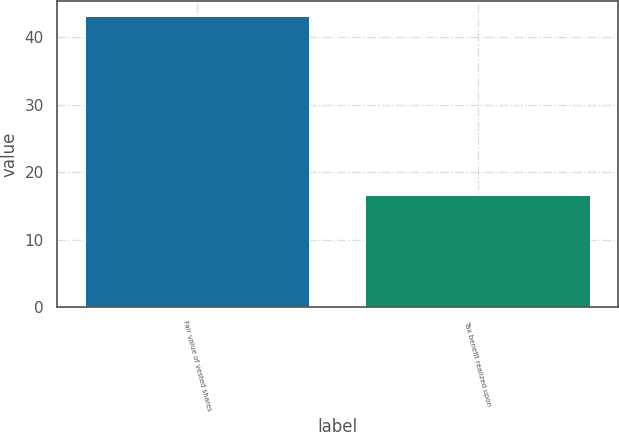<chart> <loc_0><loc_0><loc_500><loc_500><bar_chart><fcel>Fair value of vested shares<fcel>Tax benefit realized upon<nl><fcel>43.2<fcel>16.6<nl></chart> 